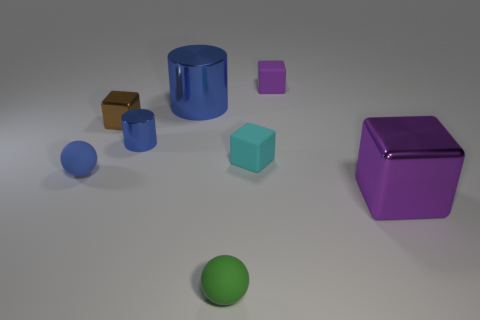If these objects had weights, which one do you think would be the heaviest? Based on their appearances, if these objects had weights proportional to their volumes and assuming they are made from materials with typical densities, the purple cube might be the heaviest due to its size and solid appearance. The metal block could also be quite heavy, especially if it's made of a dense metal like steel or iron. 